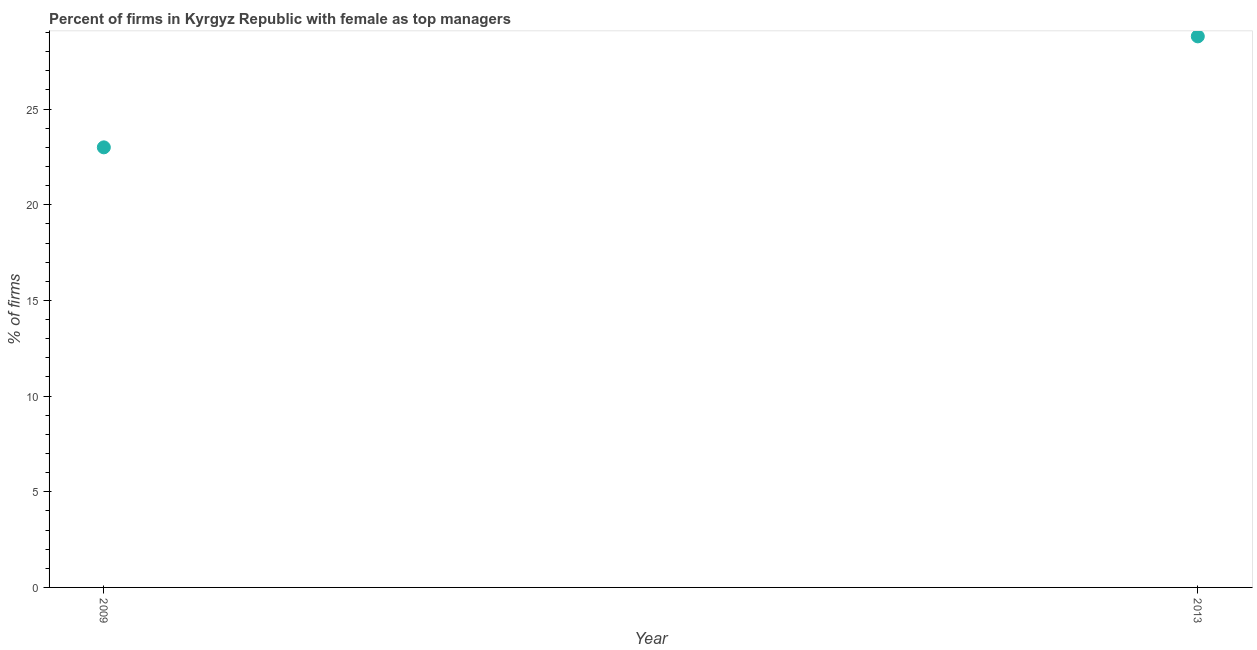Across all years, what is the maximum percentage of firms with female as top manager?
Provide a short and direct response. 28.8. Across all years, what is the minimum percentage of firms with female as top manager?
Provide a succinct answer. 23. In which year was the percentage of firms with female as top manager maximum?
Provide a short and direct response. 2013. What is the sum of the percentage of firms with female as top manager?
Your answer should be very brief. 51.8. What is the difference between the percentage of firms with female as top manager in 2009 and 2013?
Make the answer very short. -5.8. What is the average percentage of firms with female as top manager per year?
Your answer should be very brief. 25.9. What is the median percentage of firms with female as top manager?
Provide a short and direct response. 25.9. What is the ratio of the percentage of firms with female as top manager in 2009 to that in 2013?
Make the answer very short. 0.8. Does the percentage of firms with female as top manager monotonically increase over the years?
Your answer should be very brief. Yes. How many dotlines are there?
Make the answer very short. 1. How many years are there in the graph?
Offer a terse response. 2. What is the difference between two consecutive major ticks on the Y-axis?
Your answer should be very brief. 5. Are the values on the major ticks of Y-axis written in scientific E-notation?
Keep it short and to the point. No. Does the graph contain any zero values?
Provide a succinct answer. No. Does the graph contain grids?
Provide a succinct answer. No. What is the title of the graph?
Keep it short and to the point. Percent of firms in Kyrgyz Republic with female as top managers. What is the label or title of the Y-axis?
Your answer should be very brief. % of firms. What is the % of firms in 2009?
Make the answer very short. 23. What is the % of firms in 2013?
Provide a short and direct response. 28.8. What is the ratio of the % of firms in 2009 to that in 2013?
Provide a succinct answer. 0.8. 